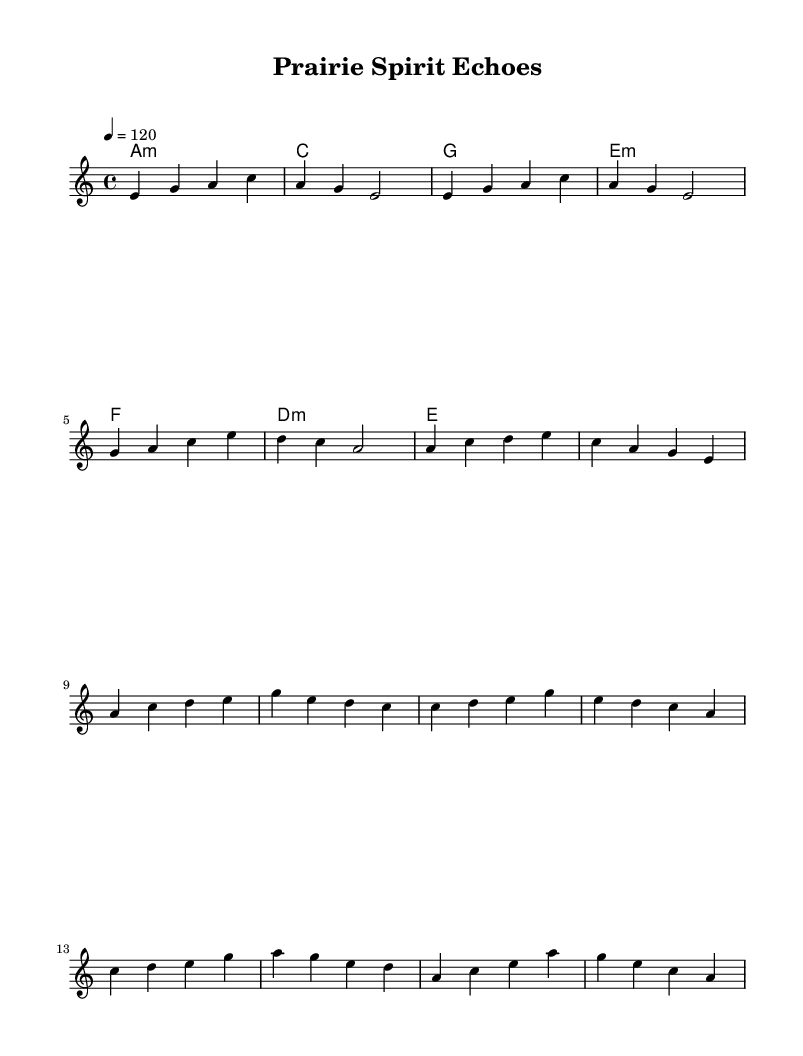What is the key signature of this music? The key signature is A minor, which has no sharps or flats. The music begins with "a" indicated in the **global** section of the code.
Answer: A minor What is the time signature of this music? The time signature is 4/4, which is shown in the **global** section. This indicates four beats per measure.
Answer: 4/4 What is the tempo of the piece? The tempo is indicated as 120 beats per minute in the **global** section where it says "tempo 4 = 120".
Answer: 120 What is the first note of the melody? The first note of the melody is E, which is the first note in the **melody** section, represented as "e4".
Answer: E What is the last harmony chord specified? The last harmony chord, as specified in the **harmonies** section, is E minor, represented as "e".
Answer: E minor Which section contains the chorus? The chorus is located after the verse in the **melody** section, starting at the measure that begins with "a4".
Answer: Chorus 